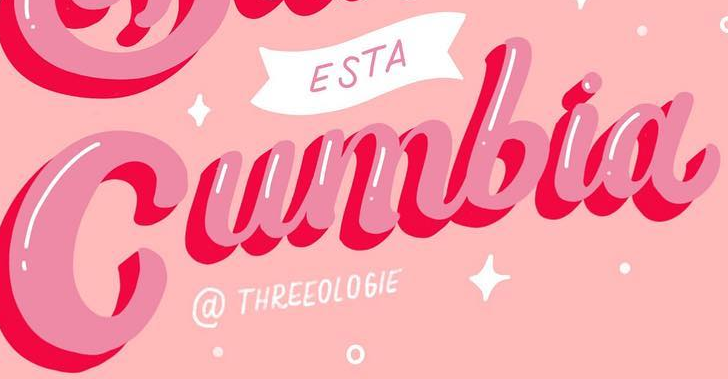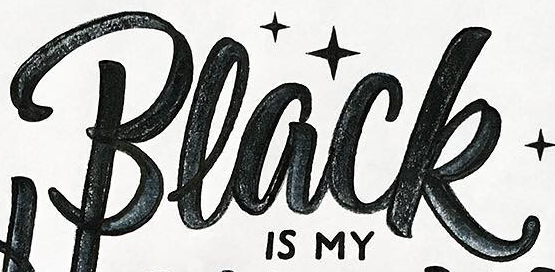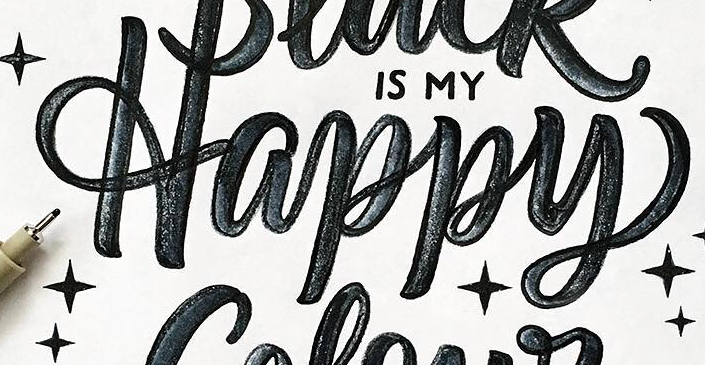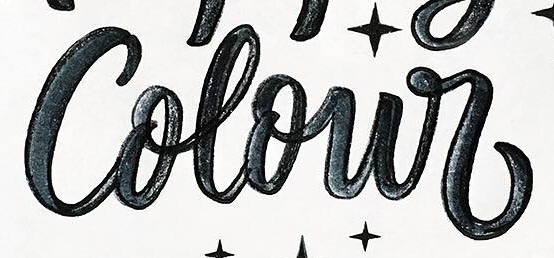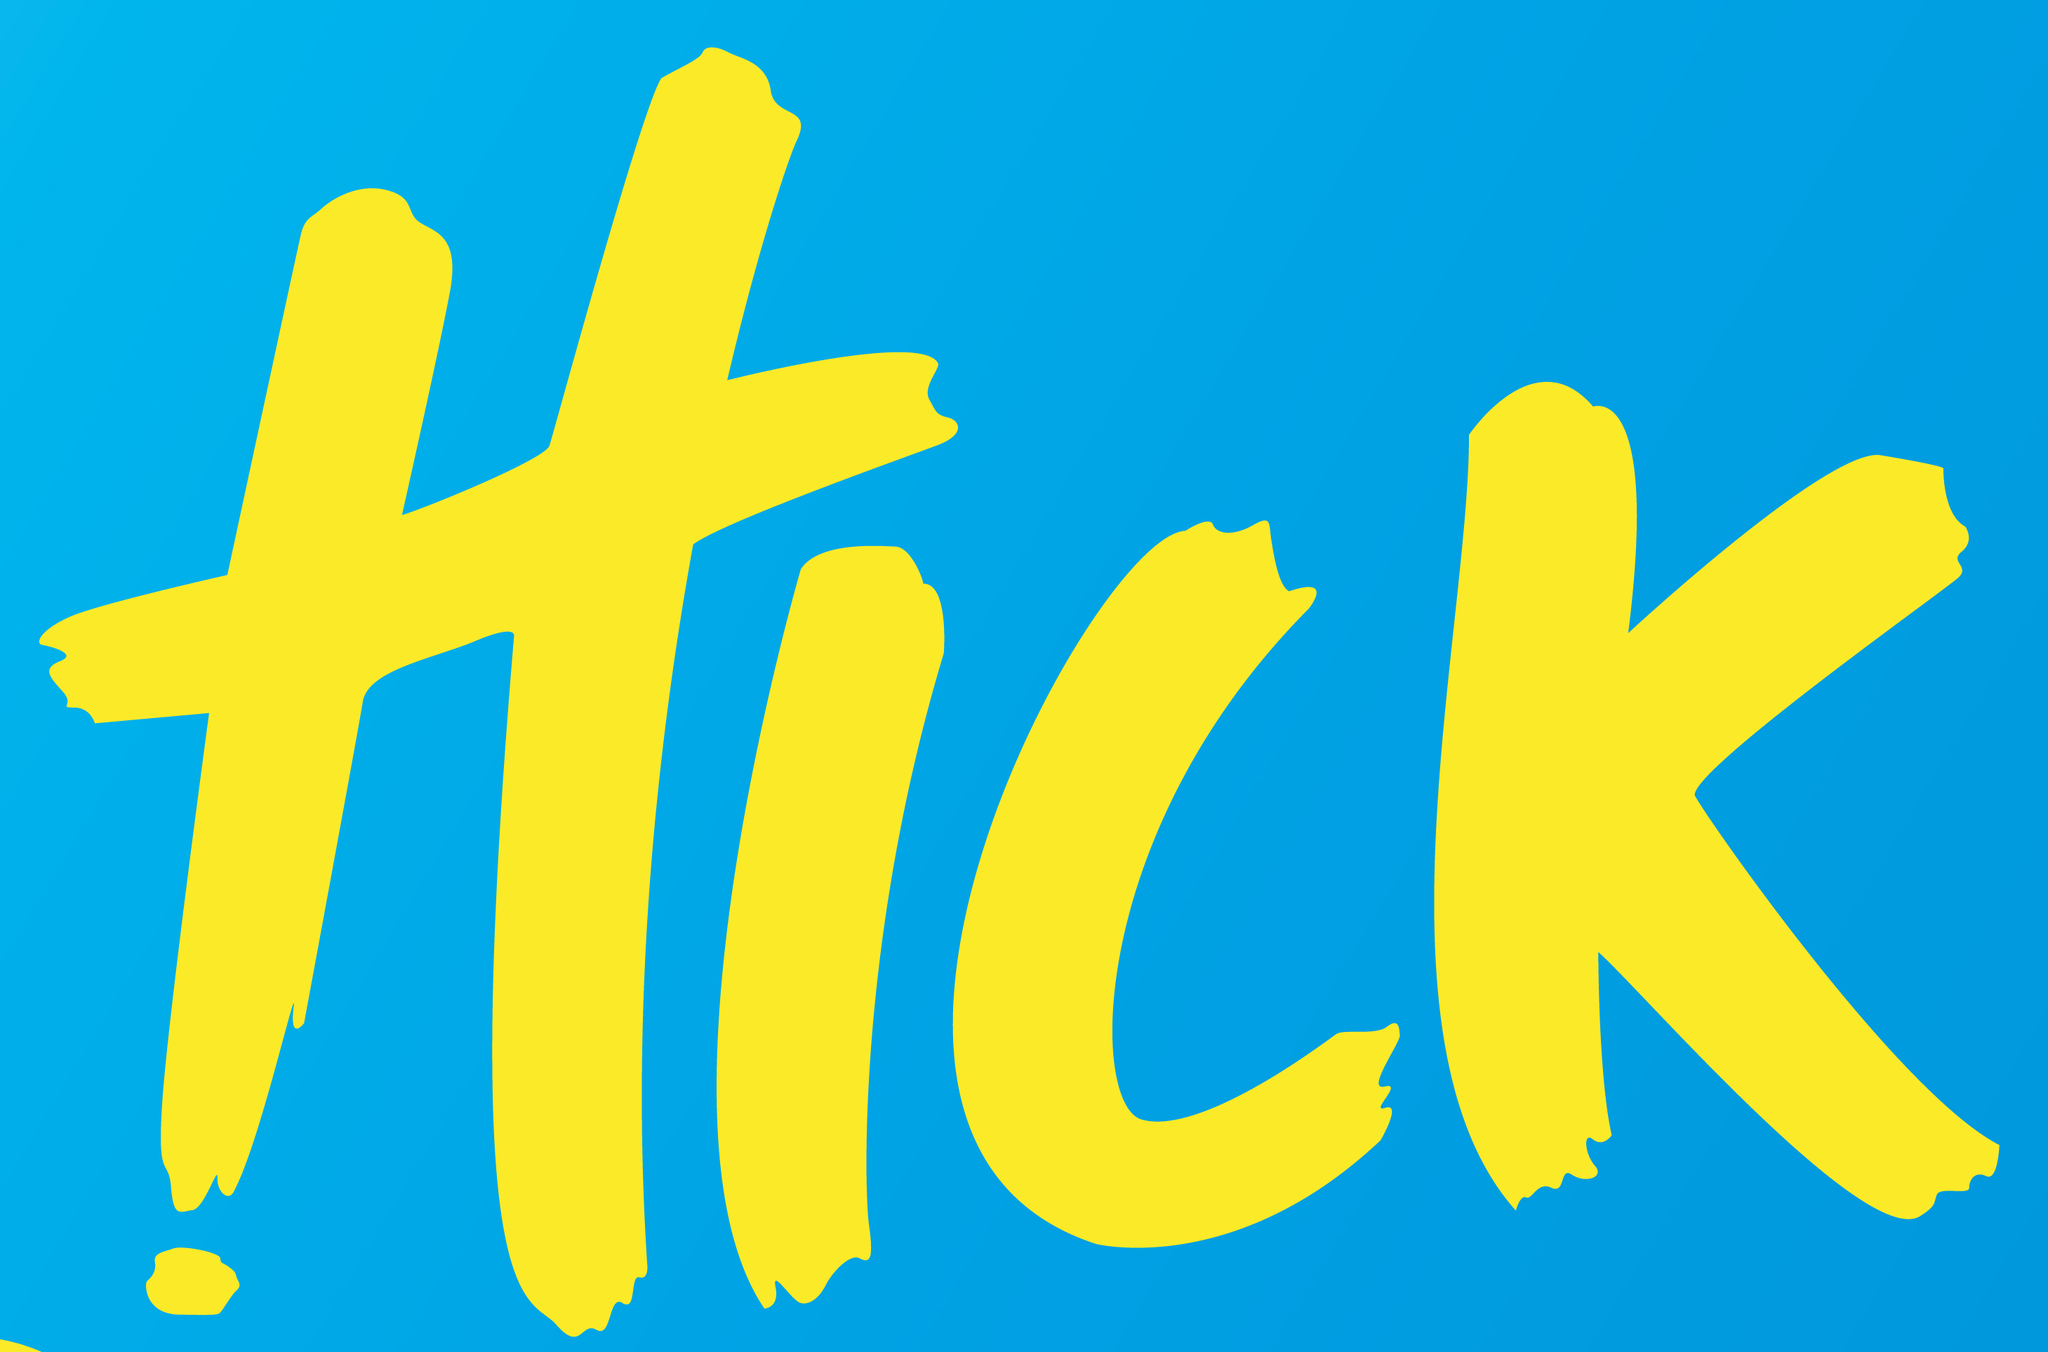What text is displayed in these images sequentially, separated by a semicolon? Cumbia; Black; Happy; Colour; HICK 